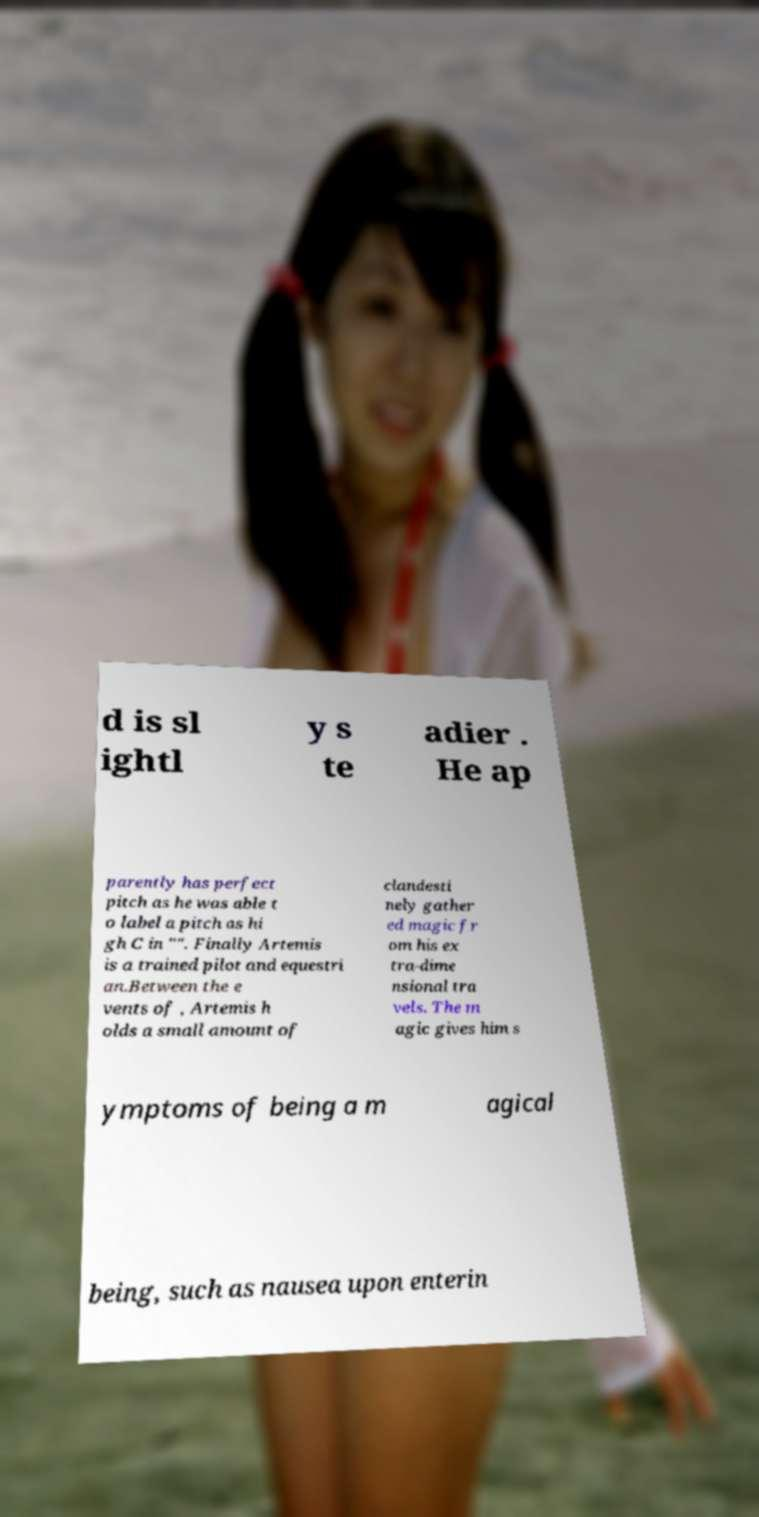Please read and relay the text visible in this image. What does it say? d is sl ightl y s te adier . He ap parently has perfect pitch as he was able t o label a pitch as hi gh C in "". Finally Artemis is a trained pilot and equestri an.Between the e vents of , Artemis h olds a small amount of clandesti nely gather ed magic fr om his ex tra-dime nsional tra vels. The m agic gives him s ymptoms of being a m agical being, such as nausea upon enterin 